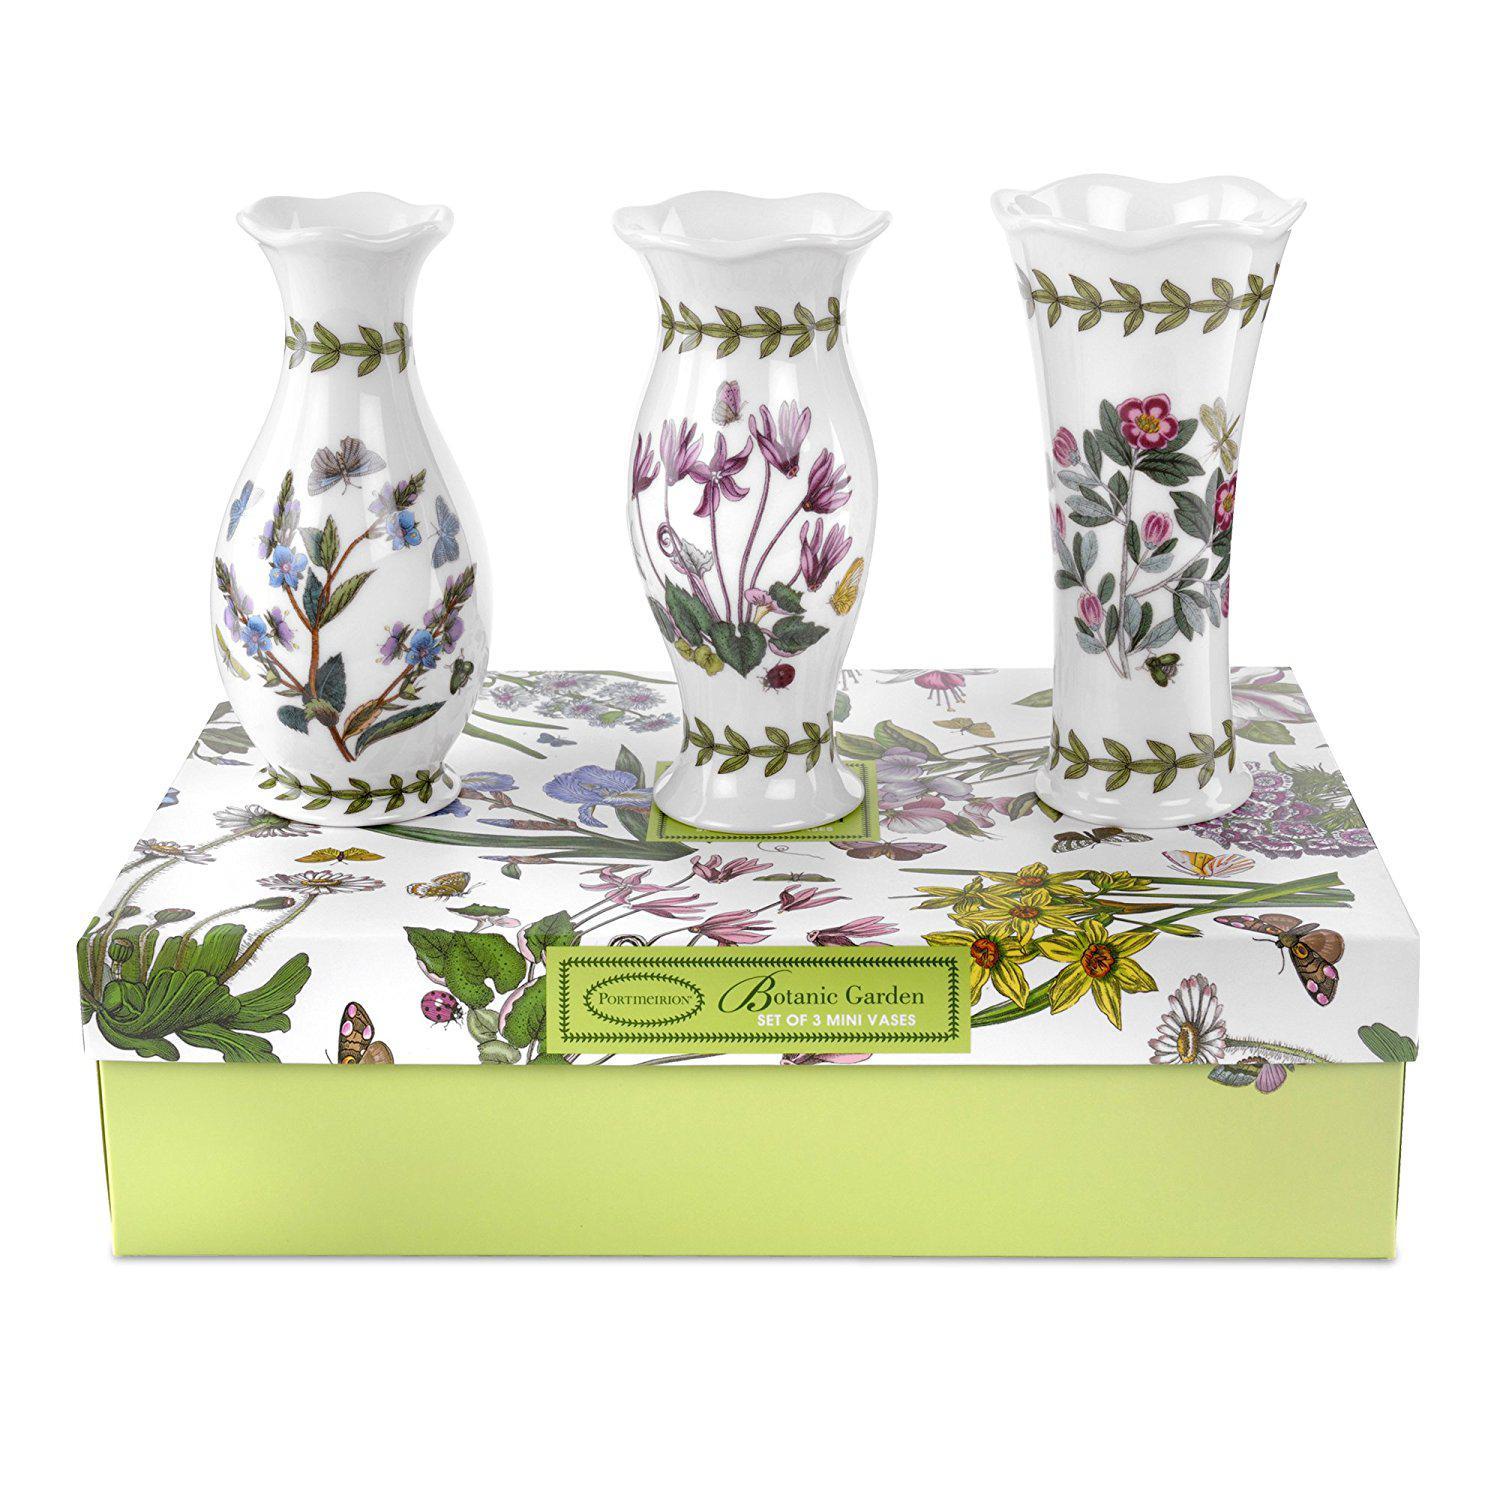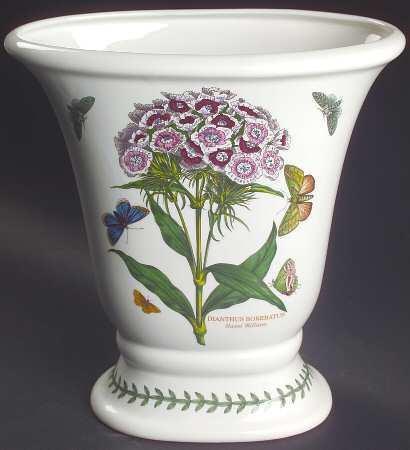The first image is the image on the left, the second image is the image on the right. Assess this claim about the two images: "Each image shows exactly one white vase, which does not hold any floral item.". Correct or not? Answer yes or no. No. The first image is the image on the left, the second image is the image on the right. Given the left and right images, does the statement "One of the two vases is decorated with digitalis flowering plants and a purple butterfly, the other vase has a blue butterfly." hold true? Answer yes or no. No. 